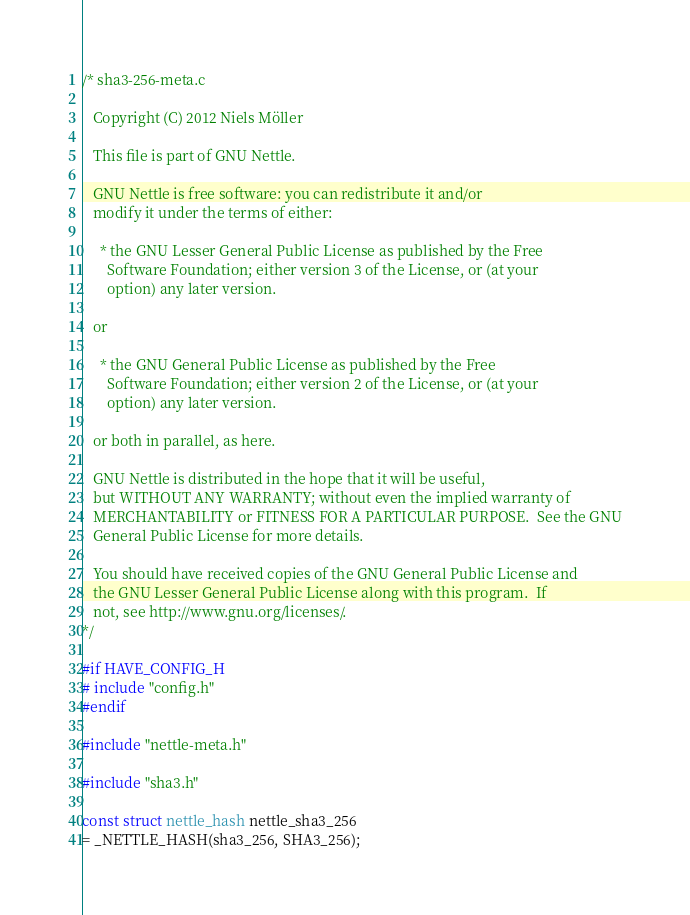Convert code to text. <code><loc_0><loc_0><loc_500><loc_500><_C_>/* sha3-256-meta.c

   Copyright (C) 2012 Niels Möller

   This file is part of GNU Nettle.

   GNU Nettle is free software: you can redistribute it and/or
   modify it under the terms of either:

     * the GNU Lesser General Public License as published by the Free
       Software Foundation; either version 3 of the License, or (at your
       option) any later version.

   or

     * the GNU General Public License as published by the Free
       Software Foundation; either version 2 of the License, or (at your
       option) any later version.

   or both in parallel, as here.

   GNU Nettle is distributed in the hope that it will be useful,
   but WITHOUT ANY WARRANTY; without even the implied warranty of
   MERCHANTABILITY or FITNESS FOR A PARTICULAR PURPOSE.  See the GNU
   General Public License for more details.

   You should have received copies of the GNU General Public License and
   the GNU Lesser General Public License along with this program.  If
   not, see http://www.gnu.org/licenses/.
*/

#if HAVE_CONFIG_H
# include "config.h"
#endif

#include "nettle-meta.h"

#include "sha3.h"

const struct nettle_hash nettle_sha3_256
= _NETTLE_HASH(sha3_256, SHA3_256);
</code> 